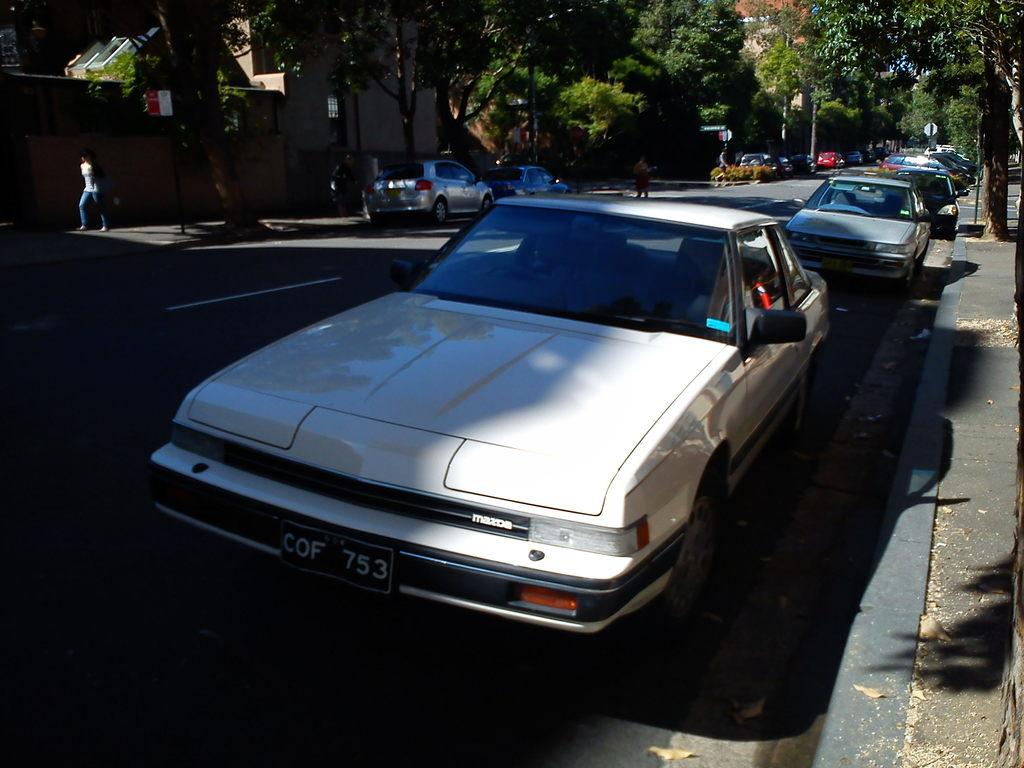What can be seen on the road in the image? There are cars parked on the road in the image. What is visible at the bottom of the image? The road is visible at the bottom of the image. What can be seen in the distance in the image? There are buildings and trees in the background of the image. What type of pencil can be seen in the image? There is no pencil present in the image. What discovery was made by the people in the image? There are no people in the image, and therefore no discovery can be observed. 